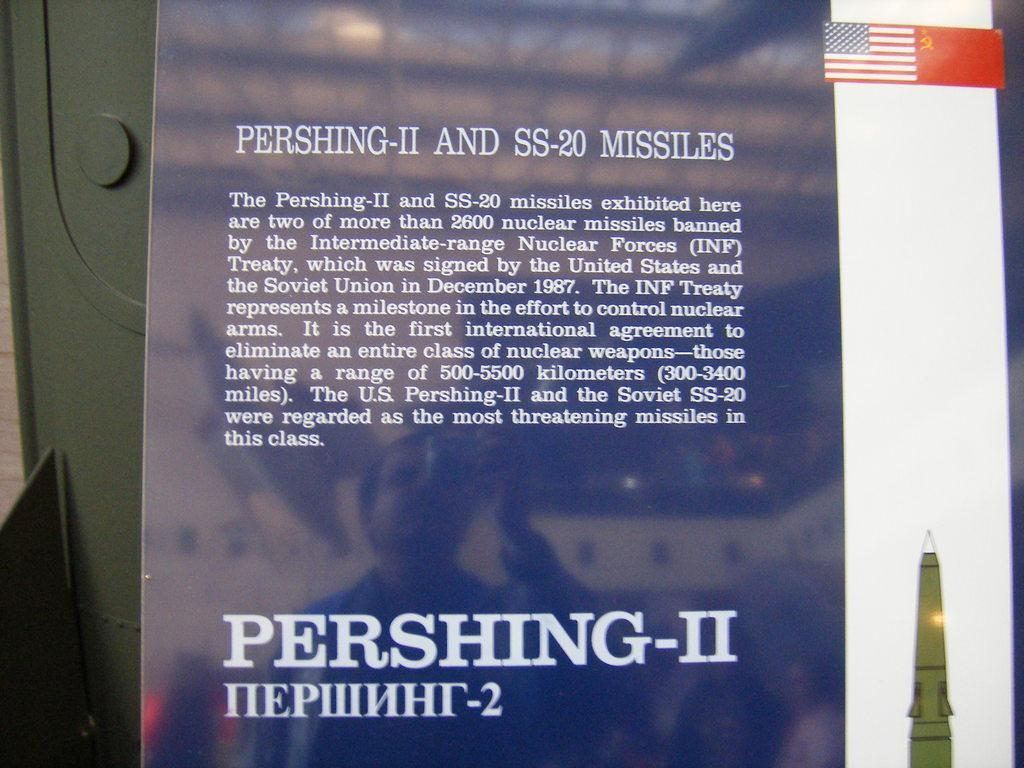<image>
Write a terse but informative summary of the picture. A blue sign describes Pershing-II and SS-20 missiles. 